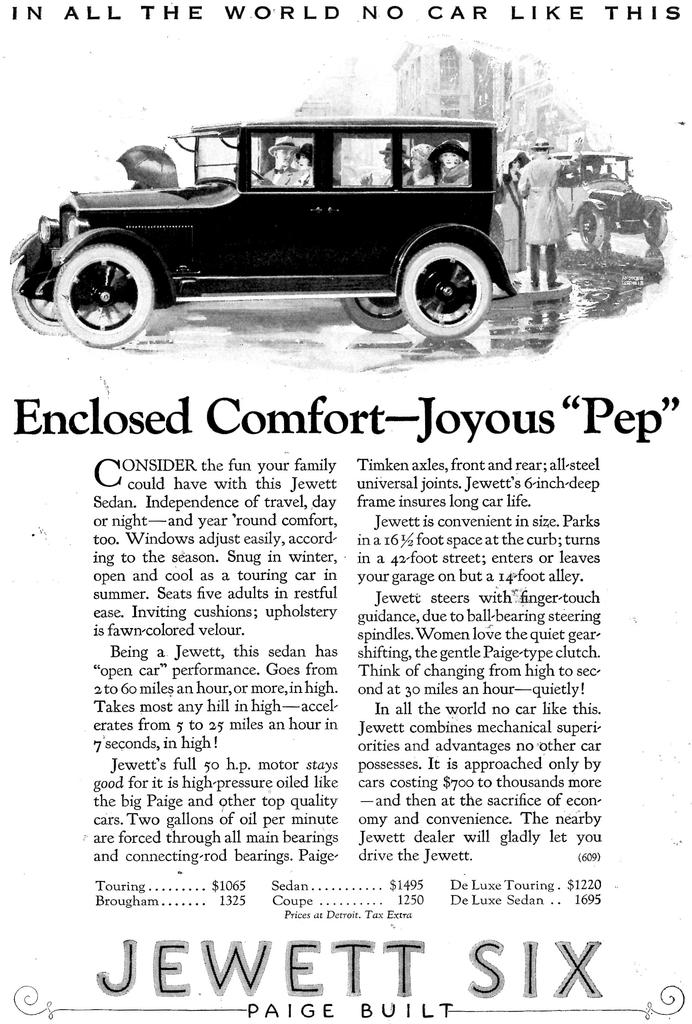What is the main subject of the image? The main subject of the image is an article. Is there any other visual element in the image besides the article? Yes, there is a picture of a car in the image. What type of room is depicted in the image? There is no room depicted in the image; it features an article and a picture of a car. What scientific theory is being discussed in the image? There is no scientific theory mentioned or discussed in the image; it only contains an article and a picture of a car. 